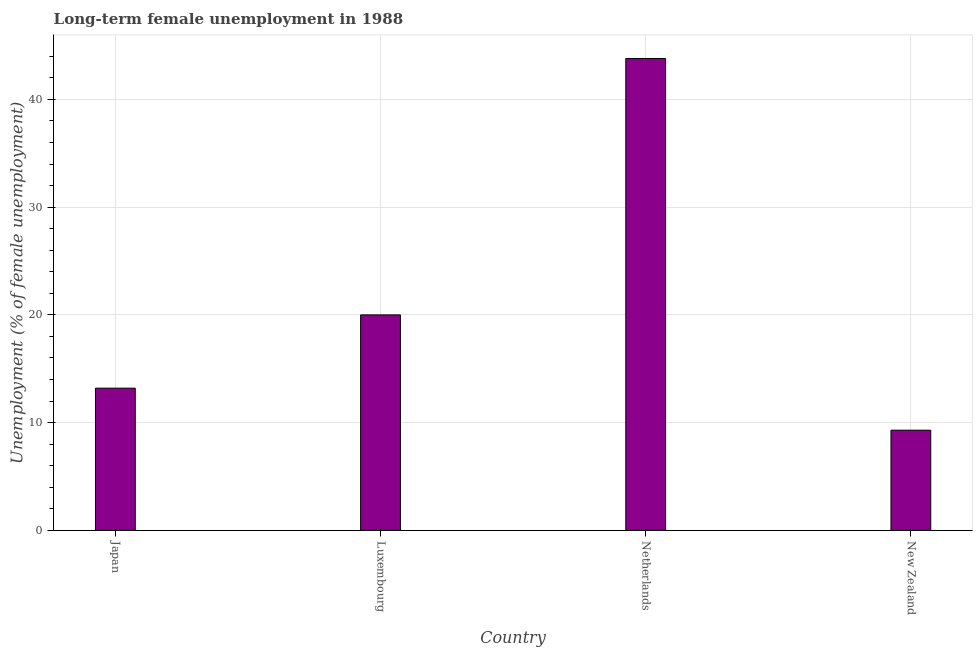What is the title of the graph?
Provide a succinct answer. Long-term female unemployment in 1988. What is the label or title of the X-axis?
Give a very brief answer. Country. What is the label or title of the Y-axis?
Your response must be concise. Unemployment (% of female unemployment). What is the long-term female unemployment in Netherlands?
Make the answer very short. 43.8. Across all countries, what is the maximum long-term female unemployment?
Your response must be concise. 43.8. Across all countries, what is the minimum long-term female unemployment?
Provide a short and direct response. 9.3. In which country was the long-term female unemployment minimum?
Your answer should be very brief. New Zealand. What is the sum of the long-term female unemployment?
Offer a very short reply. 86.3. What is the difference between the long-term female unemployment in Luxembourg and Netherlands?
Your answer should be compact. -23.8. What is the average long-term female unemployment per country?
Give a very brief answer. 21.57. What is the median long-term female unemployment?
Your answer should be very brief. 16.6. In how many countries, is the long-term female unemployment greater than 42 %?
Provide a short and direct response. 1. What is the ratio of the long-term female unemployment in Luxembourg to that in Netherlands?
Provide a succinct answer. 0.46. Is the difference between the long-term female unemployment in Japan and Luxembourg greater than the difference between any two countries?
Give a very brief answer. No. What is the difference between the highest and the second highest long-term female unemployment?
Your response must be concise. 23.8. Is the sum of the long-term female unemployment in Japan and Netherlands greater than the maximum long-term female unemployment across all countries?
Make the answer very short. Yes. What is the difference between the highest and the lowest long-term female unemployment?
Your answer should be compact. 34.5. What is the difference between two consecutive major ticks on the Y-axis?
Your answer should be compact. 10. Are the values on the major ticks of Y-axis written in scientific E-notation?
Your answer should be compact. No. What is the Unemployment (% of female unemployment) of Japan?
Provide a succinct answer. 13.2. What is the Unemployment (% of female unemployment) in Luxembourg?
Provide a succinct answer. 20. What is the Unemployment (% of female unemployment) of Netherlands?
Make the answer very short. 43.8. What is the Unemployment (% of female unemployment) in New Zealand?
Your answer should be compact. 9.3. What is the difference between the Unemployment (% of female unemployment) in Japan and Netherlands?
Make the answer very short. -30.6. What is the difference between the Unemployment (% of female unemployment) in Japan and New Zealand?
Offer a very short reply. 3.9. What is the difference between the Unemployment (% of female unemployment) in Luxembourg and Netherlands?
Your response must be concise. -23.8. What is the difference between the Unemployment (% of female unemployment) in Luxembourg and New Zealand?
Keep it short and to the point. 10.7. What is the difference between the Unemployment (% of female unemployment) in Netherlands and New Zealand?
Provide a short and direct response. 34.5. What is the ratio of the Unemployment (% of female unemployment) in Japan to that in Luxembourg?
Keep it short and to the point. 0.66. What is the ratio of the Unemployment (% of female unemployment) in Japan to that in Netherlands?
Offer a terse response. 0.3. What is the ratio of the Unemployment (% of female unemployment) in Japan to that in New Zealand?
Make the answer very short. 1.42. What is the ratio of the Unemployment (% of female unemployment) in Luxembourg to that in Netherlands?
Your response must be concise. 0.46. What is the ratio of the Unemployment (% of female unemployment) in Luxembourg to that in New Zealand?
Make the answer very short. 2.15. What is the ratio of the Unemployment (% of female unemployment) in Netherlands to that in New Zealand?
Offer a very short reply. 4.71. 